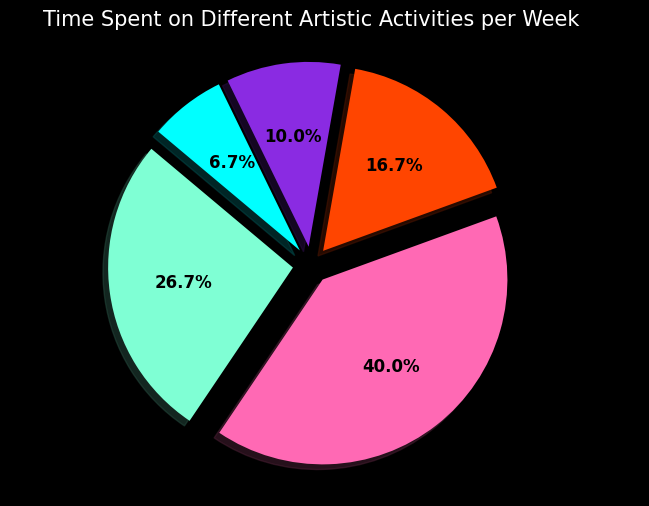What percentage of the week is spent on Marketing? The pie chart shows Marketing taking up one of the slices accompanied by a percentage label. Identify this slice and read the percentage directly from the chart.
Answer: 6.3% Which activity consumes the most time per week? Observe the size of the pie slices, the largest slice represents the activity that consumes the most time. The chart indicates Painting is the largest slice.
Answer: Painting How much more time is spent on Painting compared to Sketching? Look at the hours allocated for Painting (12 hours) and Sketching (8 hours). Subtract the hours spent on Sketching from the hours spent on Painting. 12 - 8 = 4 hours more are spent on Painting compared to Sketching.
Answer: 4 hours Which activities combined constitute less than 10 hours per week? Look for slices that, when combined, total less than 10 hours. Exhibiting Work (3 hours) and Marketing (2 hours) add up to 5 hours together, which is less than 10 hours.
Answer: Exhibiting Work and Marketing How many activities have more than 5 hours dedicated to them? Identify the slices in the pie chart representing activities that have more than 5 hours. Painting (12 hours) and Sketching (8 hours) meet this criterion, making a total of 2 activities.
Answer: 2 What color represents Concept Development, and how many hours are allocated to it? Look at the pie chart and find the slice labeled Concept Development to identify its color. Also, observe the slice's provided hour count. Concept Development is marked with a particular color (blue-violet) and has 5 hours allocated to it.
Answer: Blue-violet, 5 hours What visual effect is used to enhance the pie chart's appearance? Observe the aesthetic elements of the chart. Notably, the "explode" effect is employed, making each slice protrude slightly, and drop shadows add depth.
Answer: Explode effect and shadows If the hours spent on Marketing were doubled, which activity would it surpass in terms of time spent? Double the current hours for Marketing (2 * 2 = 4 hours). Compare 4 hours to other activities: Sketching (8), Painting (12), Concept Development (5), and Exhibiting Work (3). Marketing would surpass Exhibiting Work.
Answer: Exhibiting Work What's the combined percentage of time spent on Sketching and Exhibiting Work? Add the percentage values from the pie chart for Sketching and Exhibiting Work. Sketching is 25% and Exhibiting Work is 9.4%, resulting in a total of 25 + 9.4 = 34.4%.
Answer: 34.4% 